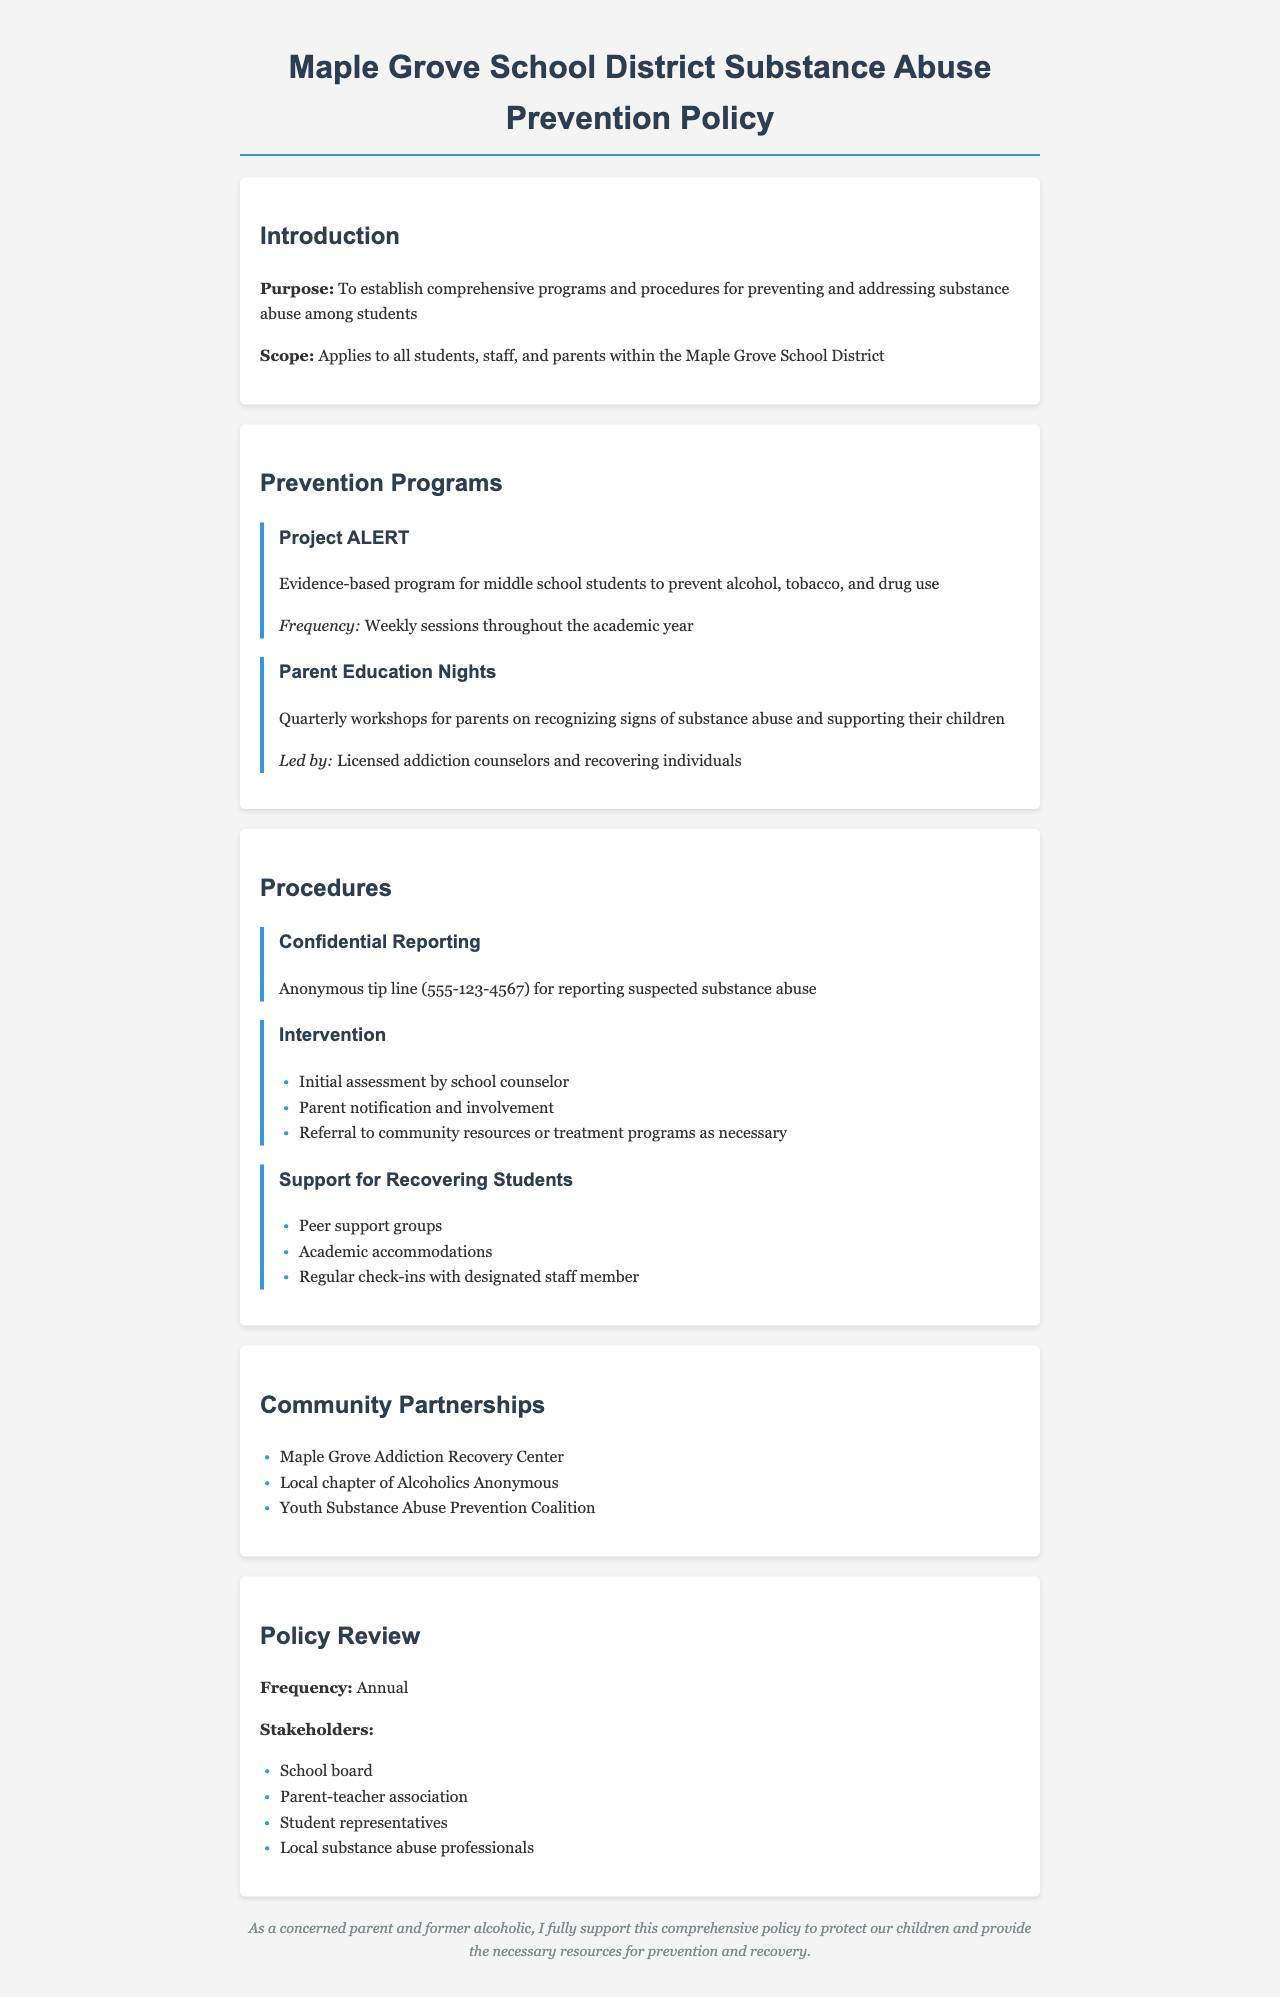What is the purpose of the policy? The purpose section states the aim of the policy, which is to establish comprehensive programs and procedures for preventing and addressing substance abuse among students.
Answer: To establish comprehensive programs and procedures for preventing and addressing substance abuse among students How often are the Parent Education Nights held? The document specifies that Parent Education Nights are workshops held quarterly for parents on recognizing signs of substance abuse.
Answer: Quarterly What is the phone number for the confidential reporting tip line? The document includes the contact information where suspected substance abuse can be reported anonymously.
Answer: 555-123-4567 Which community partnership focuses on addiction recovery? The document lists partners and specifically identifies the Maple Grove Addiction Recovery Center as a community resource related to substance abuse.
Answer: Maple Grove Addiction Recovery Center What is the frequency of the policy review? The document states how often the policy undergoes a review, which is an essential process for maintaining its relevance and effectiveness.
Answer: Annual What type of programs does Project ALERT represent? The document describes Project ALERT as an evidence-based program, emphasizing its focus on middle school students to prevent substance use.
Answer: Evidence-based program Who leads the Parent Education Nights? This question inquires about the qualifications of those facilitating the workshops for parents as stated in the document.
Answer: Licensed addiction counselors and recovering individuals What is the first step in the intervention procedure? The document outlines a series of steps in the intervention process, with the initial assessment being the first action taken.
Answer: Initial assessment by school counselor 